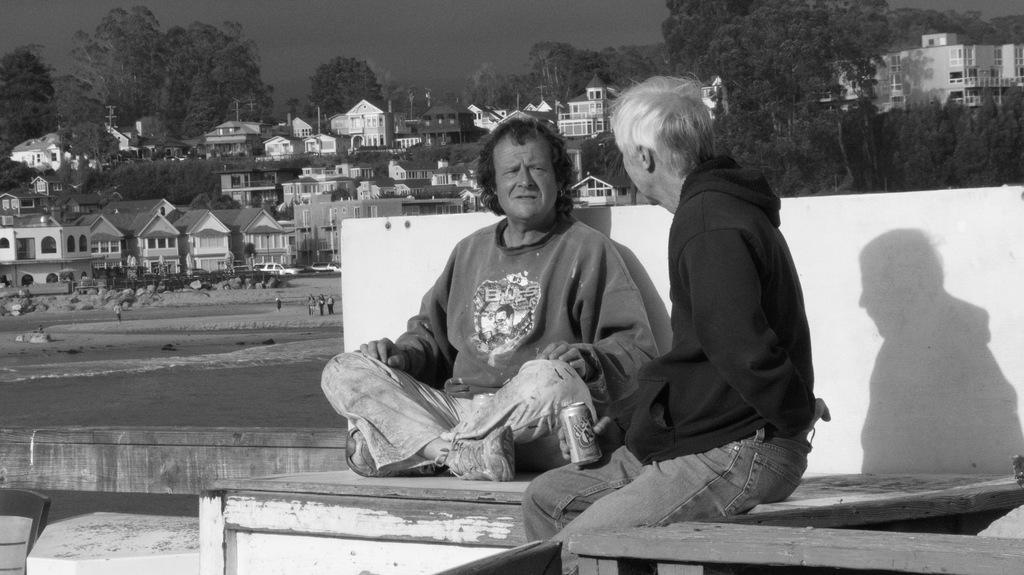In one or two sentences, can you explain what this image depicts? This image is clicked outside. There are two persons in this image. To the right, the person wearing black dress is holding a tin. They are sitting on a wooden bench. In the background, there are trees buildings, and plants. And there is a beach. 